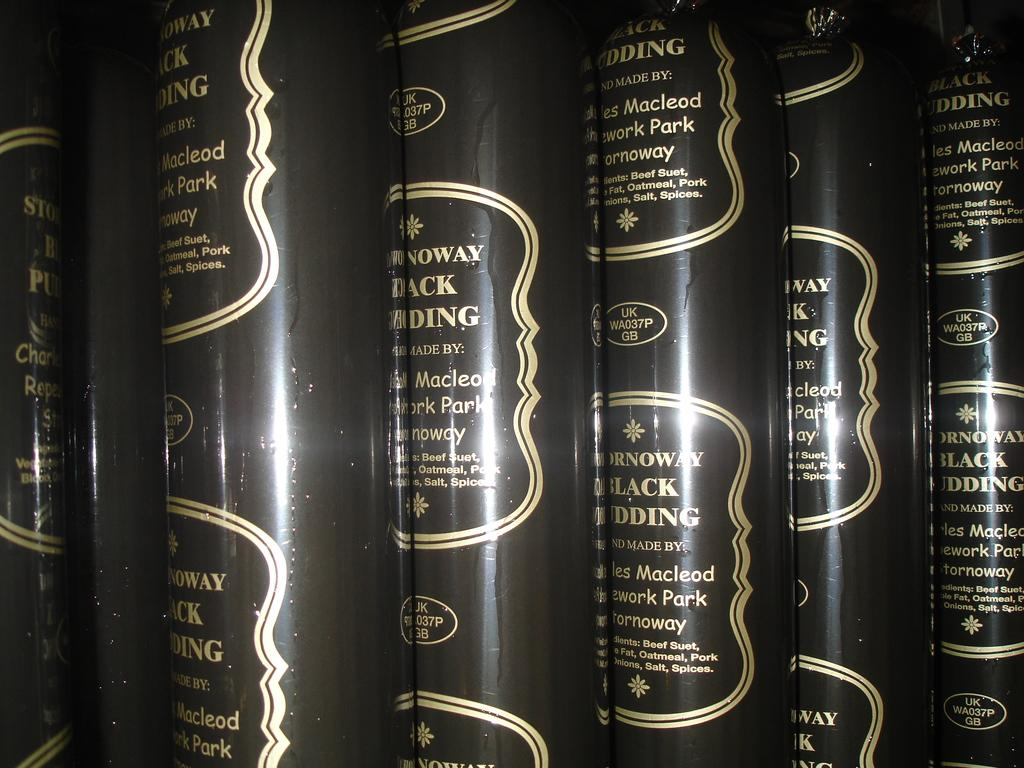<image>
Write a terse but informative summary of the picture. Six tubes of Stornoway Black Pudding are stacked side by side 